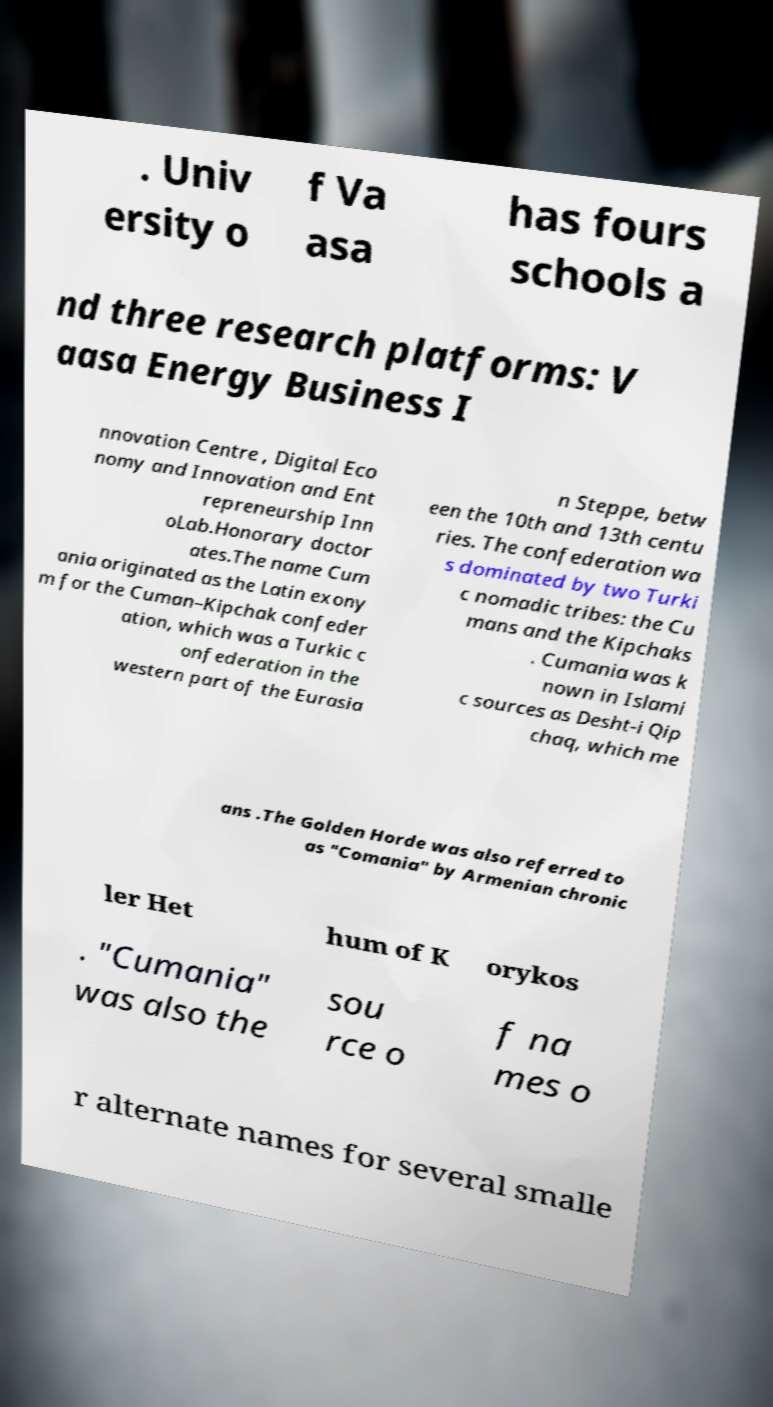There's text embedded in this image that I need extracted. Can you transcribe it verbatim? . Univ ersity o f Va asa has fours schools a nd three research platforms: V aasa Energy Business I nnovation Centre , Digital Eco nomy and Innovation and Ent repreneurship Inn oLab.Honorary doctor ates.The name Cum ania originated as the Latin exony m for the Cuman–Kipchak confeder ation, which was a Turkic c onfederation in the western part of the Eurasia n Steppe, betw een the 10th and 13th centu ries. The confederation wa s dominated by two Turki c nomadic tribes: the Cu mans and the Kipchaks . Cumania was k nown in Islami c sources as Desht-i Qip chaq, which me ans .The Golden Horde was also referred to as "Comania" by Armenian chronic ler Het hum of K orykos . "Cumania" was also the sou rce o f na mes o r alternate names for several smalle 